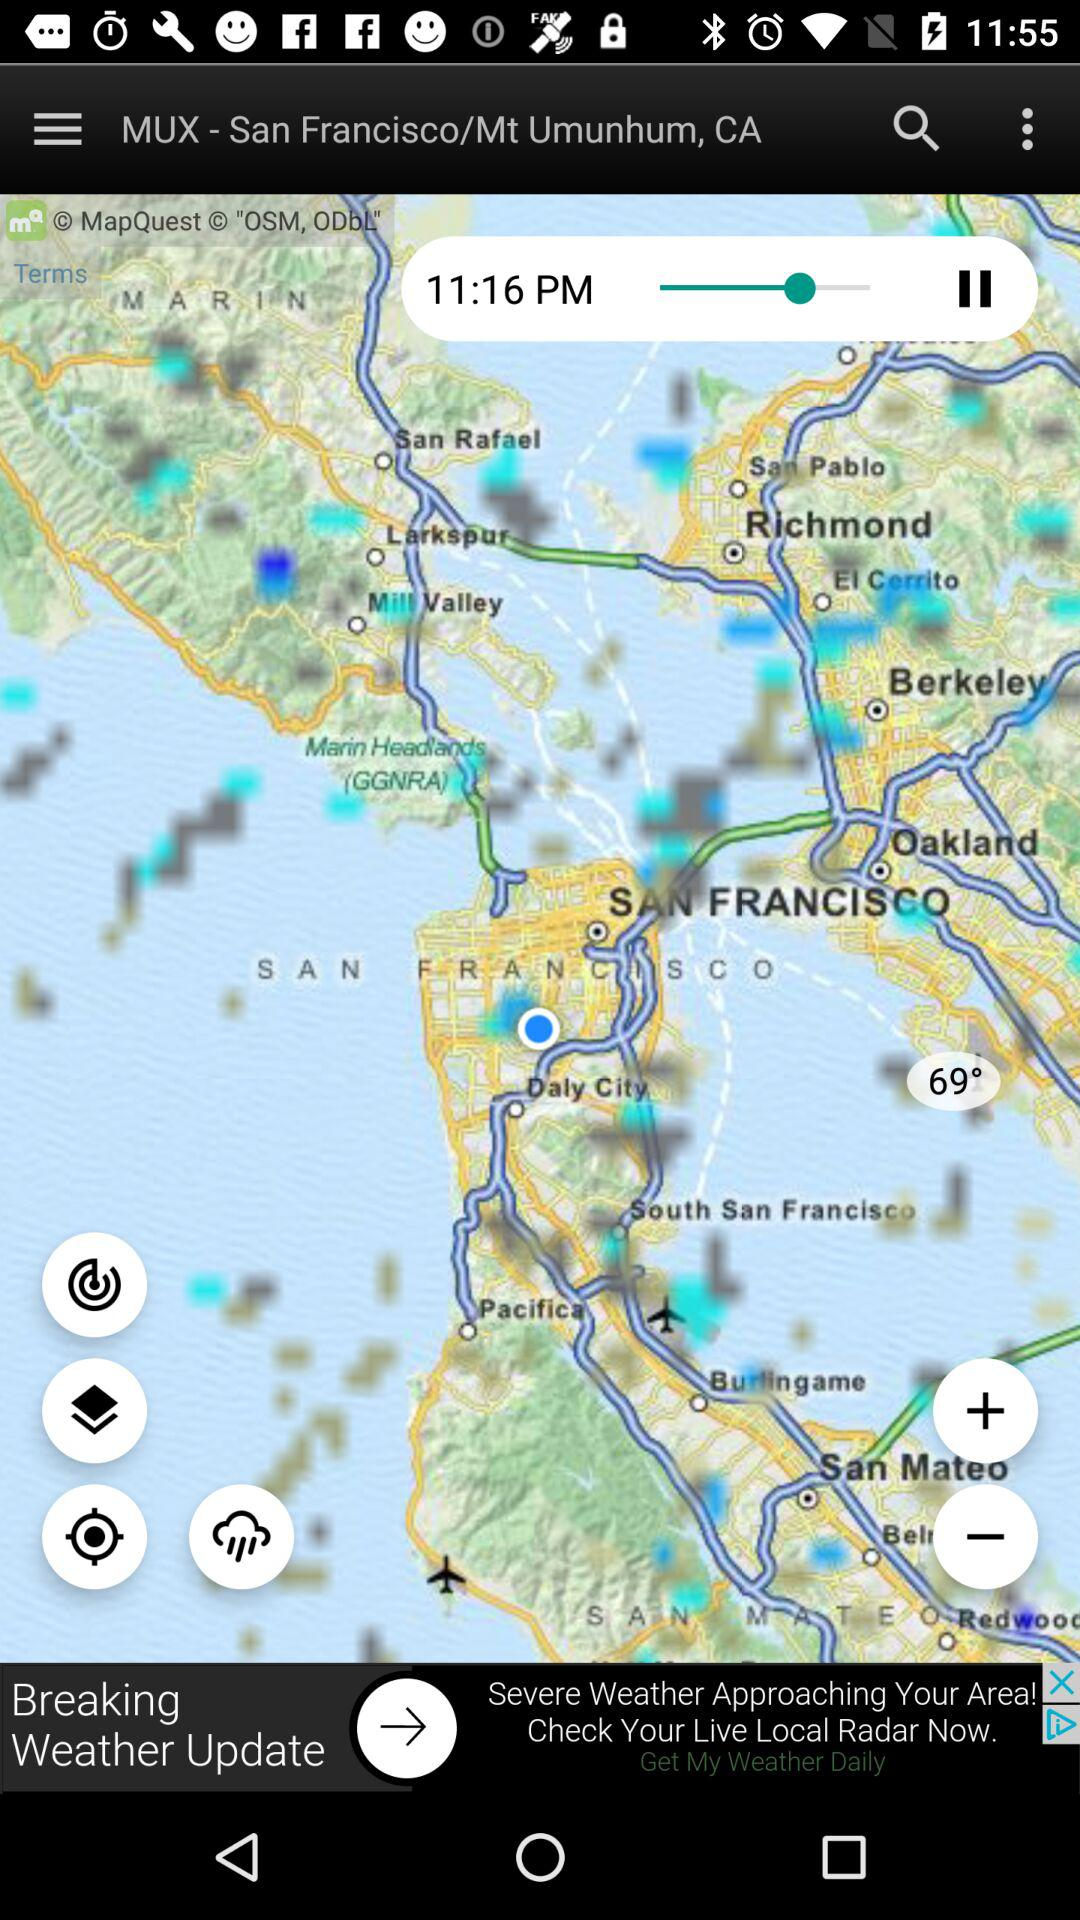What is the weather forecast given on the screen? The weather shown on the screen is rainy. 